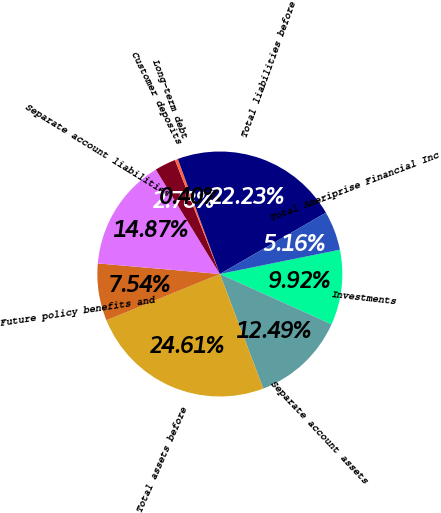<chart> <loc_0><loc_0><loc_500><loc_500><pie_chart><fcel>Investments<fcel>Separate account assets<fcel>Total assets before<fcel>Future policy benefits and<fcel>Separate account liabilities<fcel>Customer deposits<fcel>Long-term debt<fcel>Total liabilities before<fcel>Total Ameriprise Financial Inc<nl><fcel>9.92%<fcel>12.49%<fcel>24.61%<fcel>7.54%<fcel>14.87%<fcel>2.78%<fcel>0.4%<fcel>22.23%<fcel>5.16%<nl></chart> 